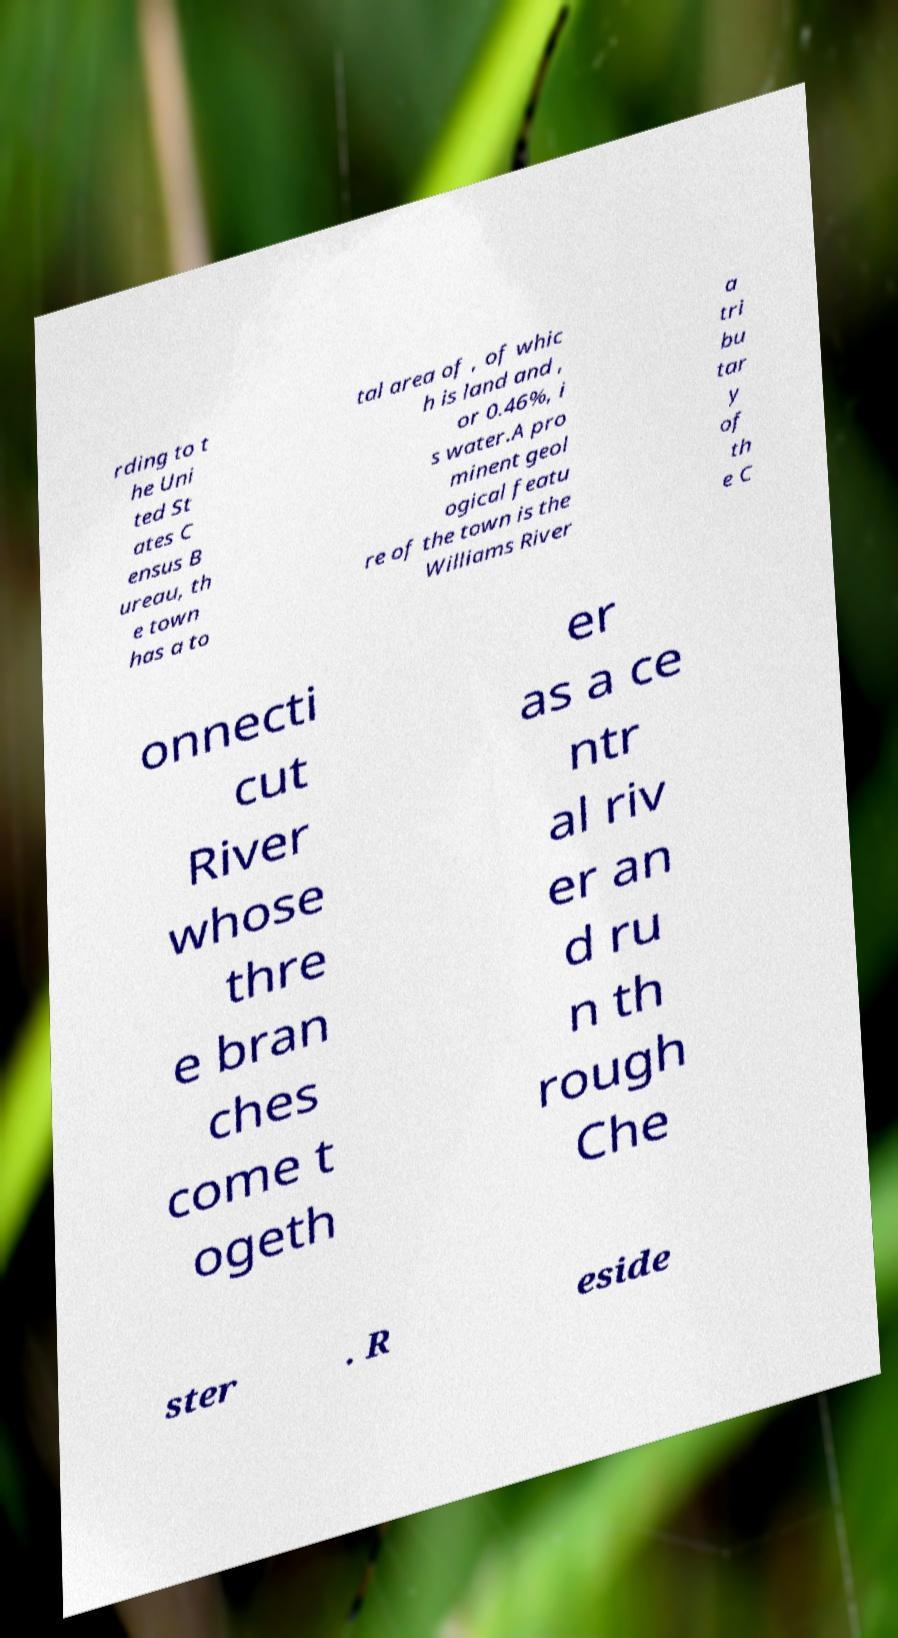Could you extract and type out the text from this image? rding to t he Uni ted St ates C ensus B ureau, th e town has a to tal area of , of whic h is land and , or 0.46%, i s water.A pro minent geol ogical featu re of the town is the Williams River a tri bu tar y of th e C onnecti cut River whose thre e bran ches come t ogeth er as a ce ntr al riv er an d ru n th rough Che ster . R eside 